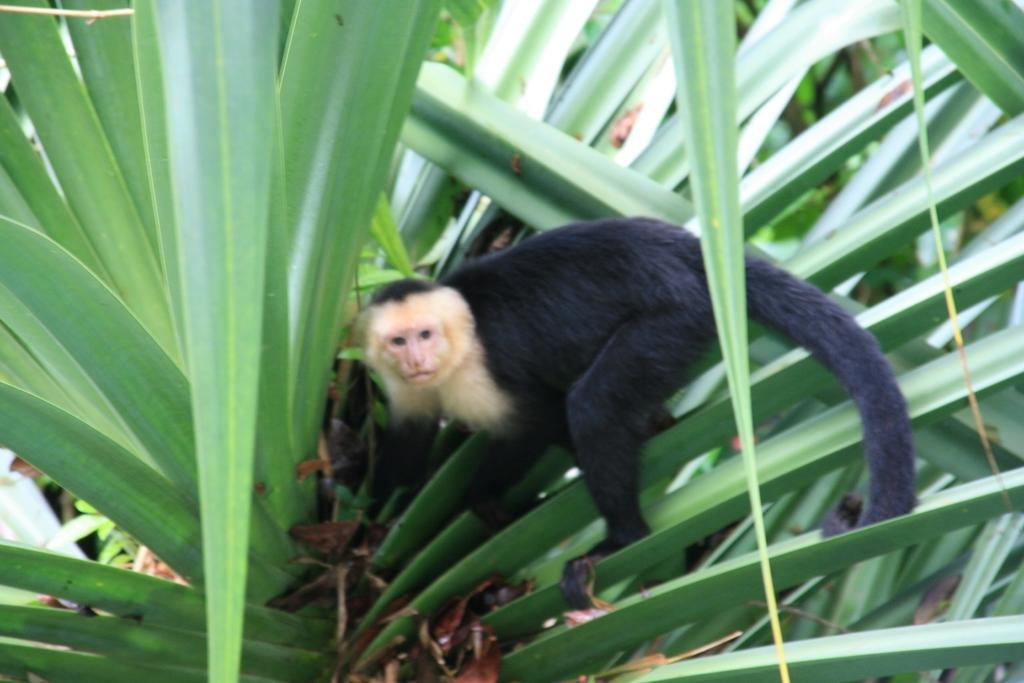What type of animal is in the image? There is a white-headed Capuchin in the image. Where is the Capuchin located in the image? The Capuchin is on a plant. What disease is the Capuchin trying to cure in the image? There is no indication in the image that the Capuchin is trying to cure a disease. How does the beginner Capuchin learn to climb the plant in the image? There is no indication in the image that the Capuchin is a beginner, nor is there any information about how it learned to climb the plant. 